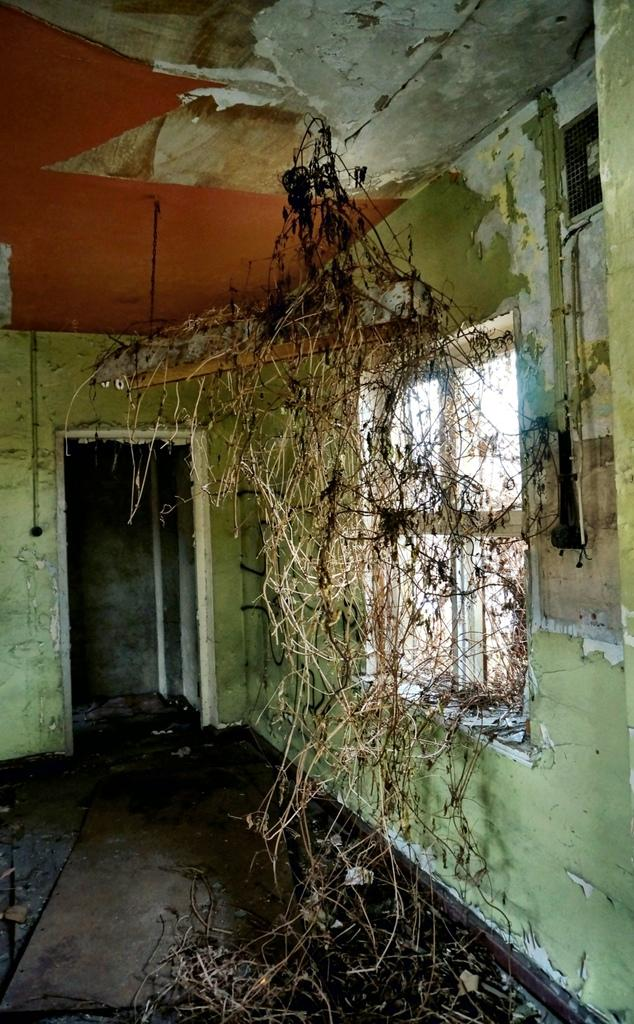What architectural feature can be seen in the image? There is a window, a floor, a wall, and a door in the image. What type of surface is visible in the image? There is a floor in the image. What is the purpose of the door in the image? The door in the image is likely used for entering or exiting a room. What type of vegetation is present in the image? Dry stems are present in the image. What type of art can be seen on the wall in the image? There is no art visible on the wall in the image; only the dry stems are present. 